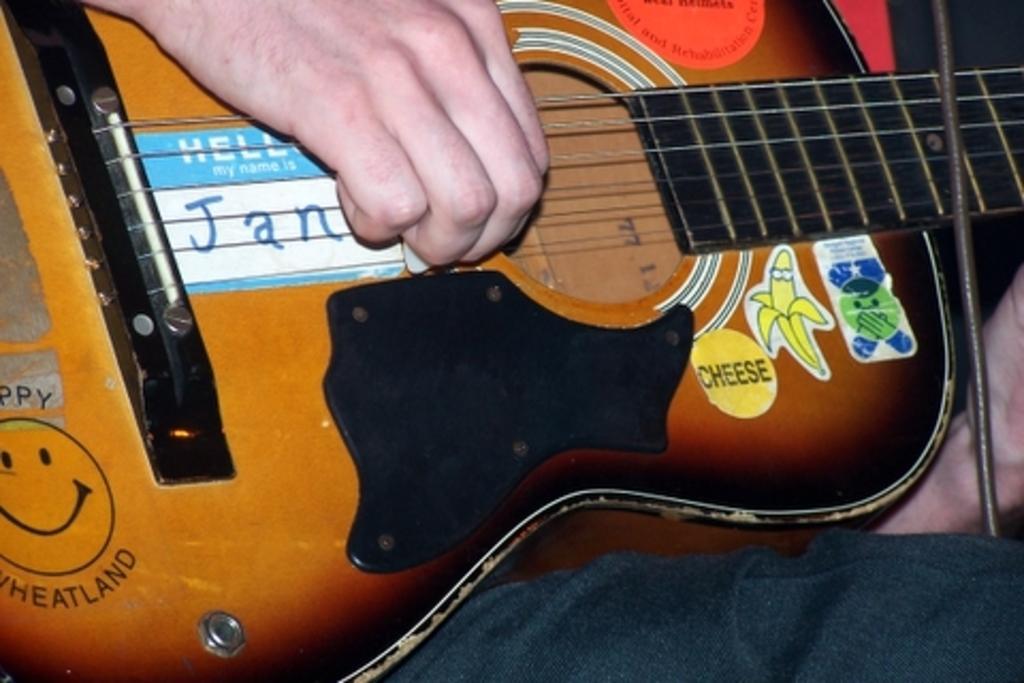In one or two sentences, can you explain what this image depicts? This picture contains the hands of a human holding guitar and this guitar is brown in color. We see some text written on that guitar. 